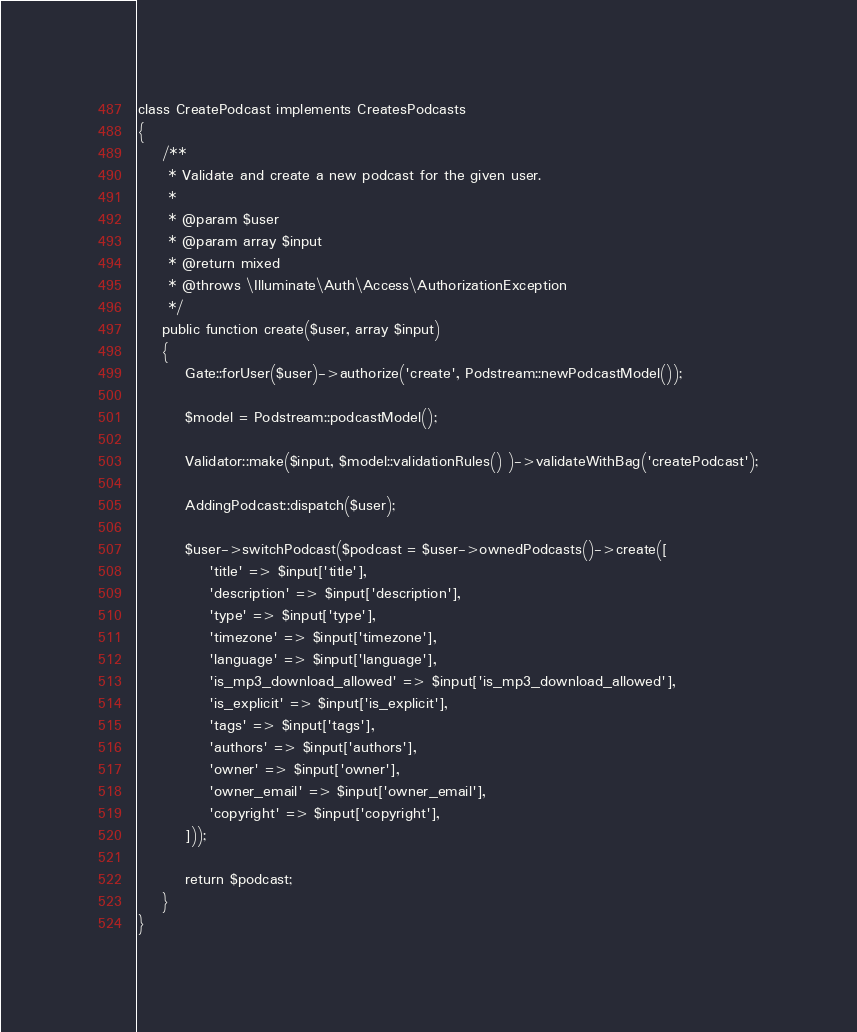Convert code to text. <code><loc_0><loc_0><loc_500><loc_500><_PHP_>
class CreatePodcast implements CreatesPodcasts
{
    /**
     * Validate and create a new podcast for the given user.
     *
     * @param $user
     * @param array $input
     * @return mixed
     * @throws \Illuminate\Auth\Access\AuthorizationException
     */
    public function create($user, array $input)
    {
        Gate::forUser($user)->authorize('create', Podstream::newPodcastModel());

        $model = Podstream::podcastModel();

        Validator::make($input, $model::validationRules() )->validateWithBag('createPodcast');

        AddingPodcast::dispatch($user);

        $user->switchPodcast($podcast = $user->ownedPodcasts()->create([
            'title' => $input['title'],
            'description' => $input['description'],
            'type' => $input['type'],
            'timezone' => $input['timezone'],
            'language' => $input['language'],
            'is_mp3_download_allowed' => $input['is_mp3_download_allowed'],
            'is_explicit' => $input['is_explicit'],
            'tags' => $input['tags'],
            'authors' => $input['authors'],
            'owner' => $input['owner'],
            'owner_email' => $input['owner_email'],
            'copyright' => $input['copyright'],
        ]));

        return $podcast;
    }
}
</code> 